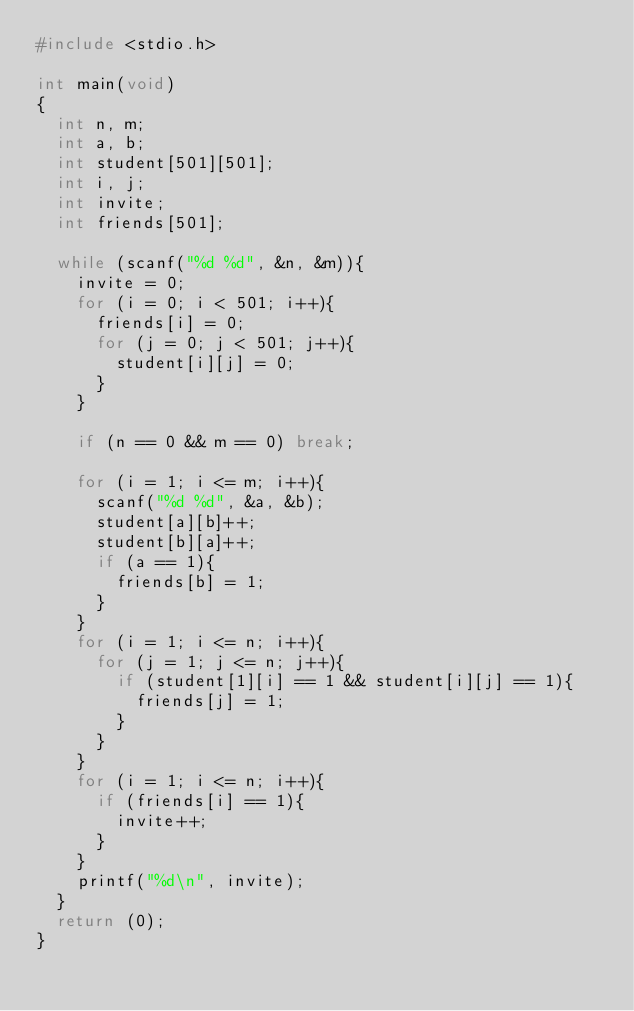Convert code to text. <code><loc_0><loc_0><loc_500><loc_500><_C_>#include <stdio.h>

int main(void)
{
	int n, m;
	int a, b;
	int student[501][501];
	int i, j;
	int invite;
	int friends[501];
	
	while (scanf("%d %d", &n, &m)){
		invite = 0;
		for (i = 0; i < 501; i++){
			friends[i] = 0;
			for (j = 0; j < 501; j++){
				student[i][j] = 0;
			}
		}
		
		if (n == 0 && m == 0) break;
		
		for (i = 1; i <= m; i++){
			scanf("%d %d", &a, &b);
			student[a][b]++;
			student[b][a]++;
			if (a == 1){
				friends[b] = 1;
			}
		}
		for (i = 1; i <= n; i++){
			for (j = 1; j <= n; j++){
				if (student[1][i] == 1 && student[i][j] == 1){
					friends[j] = 1;
				}
			}
		}
		for (i = 1; i <= n; i++){
			if (friends[i] == 1){
				invite++;
			}
		}
		printf("%d\n", invite);
	}
	return (0);
}</code> 